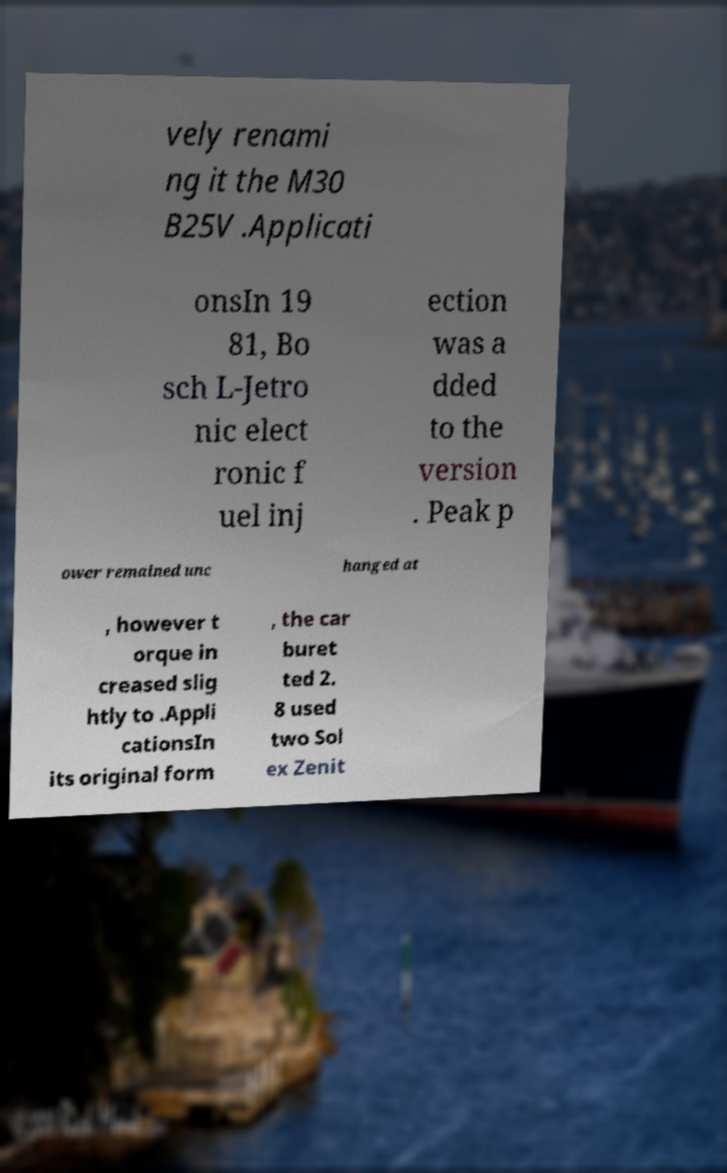Could you extract and type out the text from this image? vely renami ng it the M30 B25V .Applicati onsIn 19 81, Bo sch L-Jetro nic elect ronic f uel inj ection was a dded to the version . Peak p ower remained unc hanged at , however t orque in creased slig htly to .Appli cationsIn its original form , the car buret ted 2. 8 used two Sol ex Zenit 